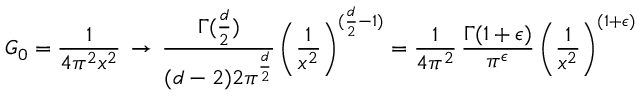Convert formula to latex. <formula><loc_0><loc_0><loc_500><loc_500>G _ { 0 } = \frac { 1 } { 4 \pi ^ { 2 } x ^ { 2 } } \, \rightarrow \, \frac { \Gamma ( \frac { d } { 2 } ) } { ( d - 2 ) 2 \pi ^ { \frac { d } { 2 } } } \, \left ( \frac { 1 } { x ^ { 2 } } \right ) ^ { ( \frac { d } { 2 } - 1 ) } = \frac { 1 } { 4 \pi ^ { 2 } } \, \frac { \Gamma ( 1 + \epsilon ) } { \pi ^ { \epsilon } } \, \left ( \frac { 1 } { x ^ { 2 } } \right ) ^ { ( 1 + \epsilon ) }</formula> 